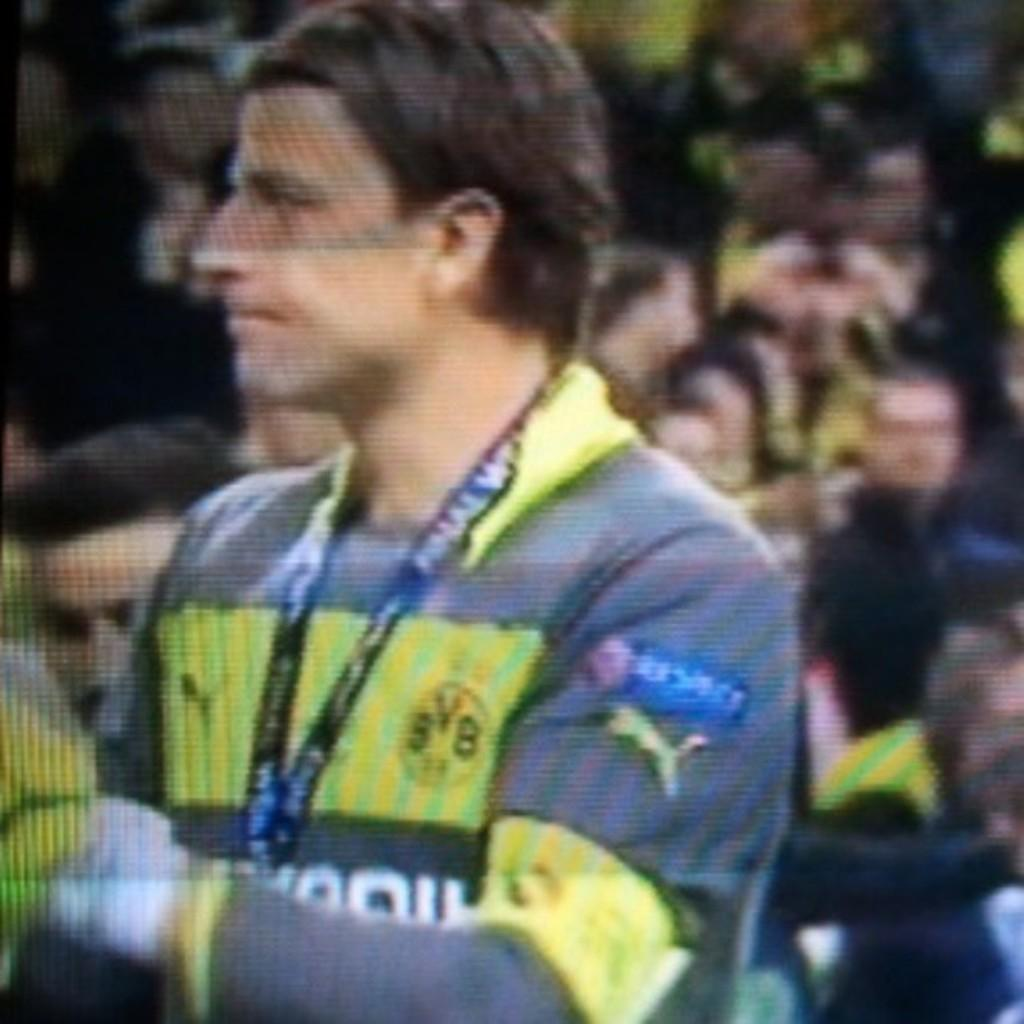What is the main subject of the image? There is a man standing in the image. Can you describe any specific details about the man? The man is wearing a tag around his neck. What is the background of the image like? There are many people behind the man, and the image appears to be taken on a television set. What type of cap is the man wearing in the image? There is no cap visible in the image; the man is wearing a tag around his neck. 